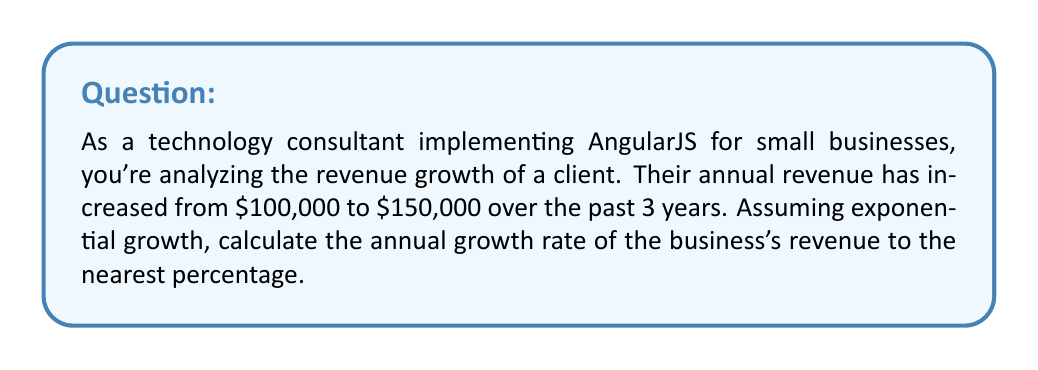Can you solve this math problem? To solve this problem, we'll use the exponential growth formula:

$$A = P(1 + r)^t$$

Where:
$A$ = Final amount
$P$ = Initial amount
$r$ = Annual growth rate (as a decimal)
$t$ = Time period (in years)

Given:
$A = $150,000$
$P = $100,000$
$t = 3$ years

Step 1: Substitute the known values into the formula:
$$150,000 = 100,000(1 + r)^3$$

Step 2: Divide both sides by 100,000:
$$1.5 = (1 + r)^3$$

Step 3: Take the cube root of both sides:
$$\sqrt[3]{1.5} = 1 + r$$

Step 4: Subtract 1 from both sides:
$$\sqrt[3]{1.5} - 1 = r$$

Step 5: Calculate the value of $r$:
$$r \approx 0.1447$$

Step 6: Convert to a percentage:
$$0.1447 \times 100\% \approx 14.47\%$$

Step 7: Round to the nearest percentage:
$$14.47\% \approx 14\%$$

Therefore, the annual growth rate of the business's revenue is approximately 14%.
Answer: 14% 